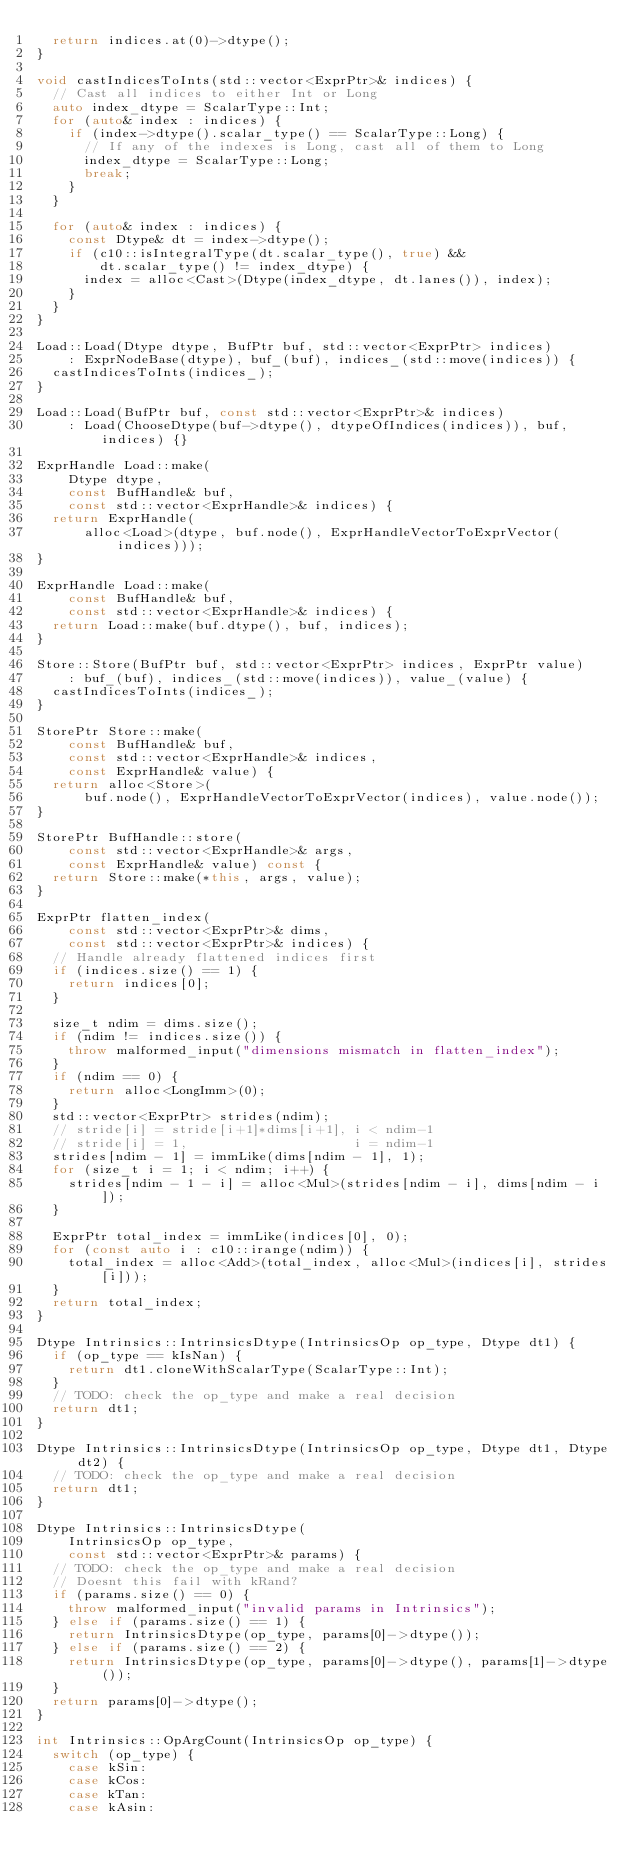Convert code to text. <code><loc_0><loc_0><loc_500><loc_500><_C++_>  return indices.at(0)->dtype();
}

void castIndicesToInts(std::vector<ExprPtr>& indices) {
  // Cast all indices to either Int or Long
  auto index_dtype = ScalarType::Int;
  for (auto& index : indices) {
    if (index->dtype().scalar_type() == ScalarType::Long) {
      // If any of the indexes is Long, cast all of them to Long
      index_dtype = ScalarType::Long;
      break;
    }
  }

  for (auto& index : indices) {
    const Dtype& dt = index->dtype();
    if (c10::isIntegralType(dt.scalar_type(), true) &&
        dt.scalar_type() != index_dtype) {
      index = alloc<Cast>(Dtype(index_dtype, dt.lanes()), index);
    }
  }
}

Load::Load(Dtype dtype, BufPtr buf, std::vector<ExprPtr> indices)
    : ExprNodeBase(dtype), buf_(buf), indices_(std::move(indices)) {
  castIndicesToInts(indices_);
}

Load::Load(BufPtr buf, const std::vector<ExprPtr>& indices)
    : Load(ChooseDtype(buf->dtype(), dtypeOfIndices(indices)), buf, indices) {}

ExprHandle Load::make(
    Dtype dtype,
    const BufHandle& buf,
    const std::vector<ExprHandle>& indices) {
  return ExprHandle(
      alloc<Load>(dtype, buf.node(), ExprHandleVectorToExprVector(indices)));
}

ExprHandle Load::make(
    const BufHandle& buf,
    const std::vector<ExprHandle>& indices) {
  return Load::make(buf.dtype(), buf, indices);
}

Store::Store(BufPtr buf, std::vector<ExprPtr> indices, ExprPtr value)
    : buf_(buf), indices_(std::move(indices)), value_(value) {
  castIndicesToInts(indices_);
}

StorePtr Store::make(
    const BufHandle& buf,
    const std::vector<ExprHandle>& indices,
    const ExprHandle& value) {
  return alloc<Store>(
      buf.node(), ExprHandleVectorToExprVector(indices), value.node());
}

StorePtr BufHandle::store(
    const std::vector<ExprHandle>& args,
    const ExprHandle& value) const {
  return Store::make(*this, args, value);
}

ExprPtr flatten_index(
    const std::vector<ExprPtr>& dims,
    const std::vector<ExprPtr>& indices) {
  // Handle already flattened indices first
  if (indices.size() == 1) {
    return indices[0];
  }

  size_t ndim = dims.size();
  if (ndim != indices.size()) {
    throw malformed_input("dimensions mismatch in flatten_index");
  }
  if (ndim == 0) {
    return alloc<LongImm>(0);
  }
  std::vector<ExprPtr> strides(ndim);
  // stride[i] = stride[i+1]*dims[i+1], i < ndim-1
  // stride[i] = 1,                     i = ndim-1
  strides[ndim - 1] = immLike(dims[ndim - 1], 1);
  for (size_t i = 1; i < ndim; i++) {
    strides[ndim - 1 - i] = alloc<Mul>(strides[ndim - i], dims[ndim - i]);
  }

  ExprPtr total_index = immLike(indices[0], 0);
  for (const auto i : c10::irange(ndim)) {
    total_index = alloc<Add>(total_index, alloc<Mul>(indices[i], strides[i]));
  }
  return total_index;
}

Dtype Intrinsics::IntrinsicsDtype(IntrinsicsOp op_type, Dtype dt1) {
  if (op_type == kIsNan) {
    return dt1.cloneWithScalarType(ScalarType::Int);
  }
  // TODO: check the op_type and make a real decision
  return dt1;
}

Dtype Intrinsics::IntrinsicsDtype(IntrinsicsOp op_type, Dtype dt1, Dtype dt2) {
  // TODO: check the op_type and make a real decision
  return dt1;
}

Dtype Intrinsics::IntrinsicsDtype(
    IntrinsicsOp op_type,
    const std::vector<ExprPtr>& params) {
  // TODO: check the op_type and make a real decision
  // Doesnt this fail with kRand?
  if (params.size() == 0) {
    throw malformed_input("invalid params in Intrinsics");
  } else if (params.size() == 1) {
    return IntrinsicsDtype(op_type, params[0]->dtype());
  } else if (params.size() == 2) {
    return IntrinsicsDtype(op_type, params[0]->dtype(), params[1]->dtype());
  }
  return params[0]->dtype();
}

int Intrinsics::OpArgCount(IntrinsicsOp op_type) {
  switch (op_type) {
    case kSin:
    case kCos:
    case kTan:
    case kAsin:</code> 